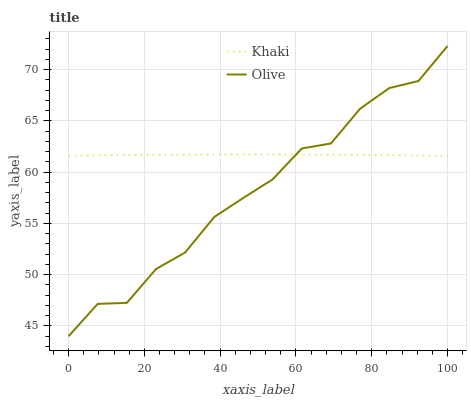Does Olive have the minimum area under the curve?
Answer yes or no. Yes. Does Khaki have the maximum area under the curve?
Answer yes or no. Yes. Does Khaki have the minimum area under the curve?
Answer yes or no. No. Is Khaki the smoothest?
Answer yes or no. Yes. Is Olive the roughest?
Answer yes or no. Yes. Is Khaki the roughest?
Answer yes or no. No. Does Khaki have the lowest value?
Answer yes or no. No. Does Khaki have the highest value?
Answer yes or no. No. 